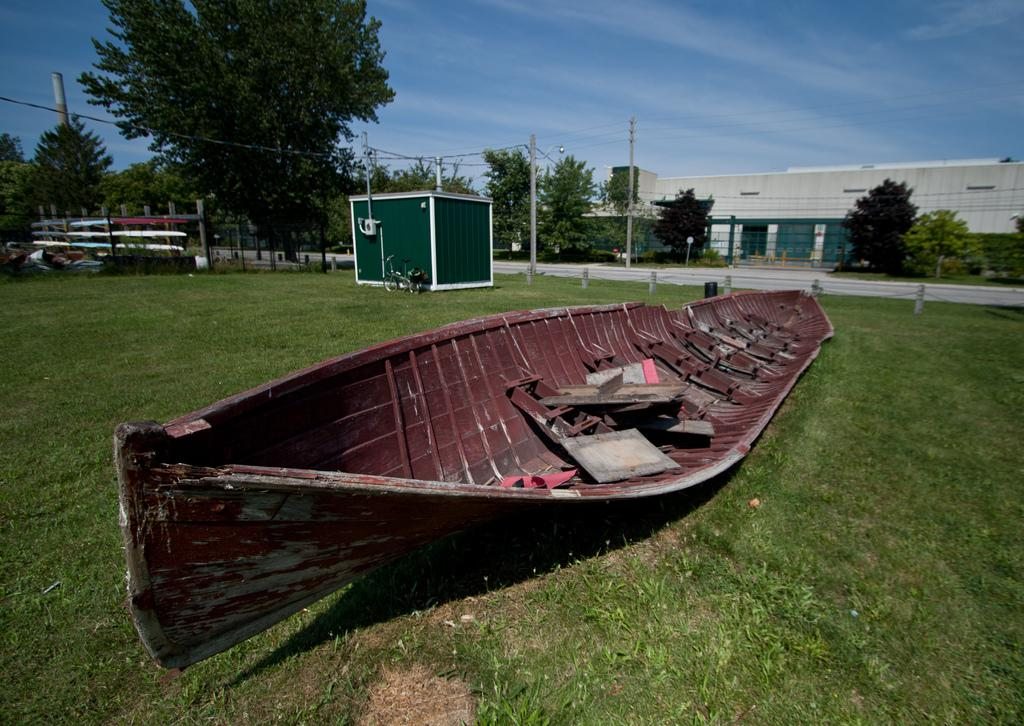What is placed on the grass in the image? There is a boat on the grass. What objects can be seen in the image besides the boat? There are poles and trees in the image. What type of barrier is present on the left side of the image? There is fencing on the left side of the image. What can be seen in the background of the image? There are buildings in the background of the image. How many times does the boat cry in the image? The boat does not cry in the image; it is an inanimate object. What type of pie is being served on the boat in the image? There is no pie present in the image; it features a boat on the grass with poles, trees, fencing, and buildings in the background. 